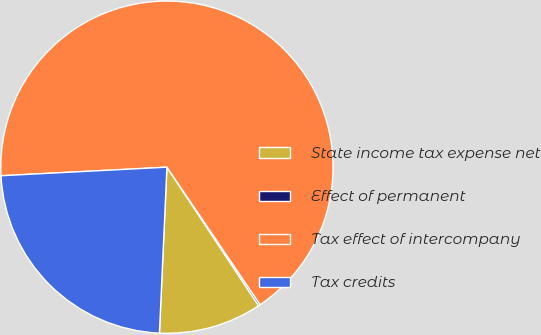Convert chart to OTSL. <chart><loc_0><loc_0><loc_500><loc_500><pie_chart><fcel>State income tax expense net<fcel>Effect of permanent<fcel>Tax effect of intercompany<fcel>Tax credits<nl><fcel>10.02%<fcel>0.18%<fcel>66.34%<fcel>23.46%<nl></chart> 